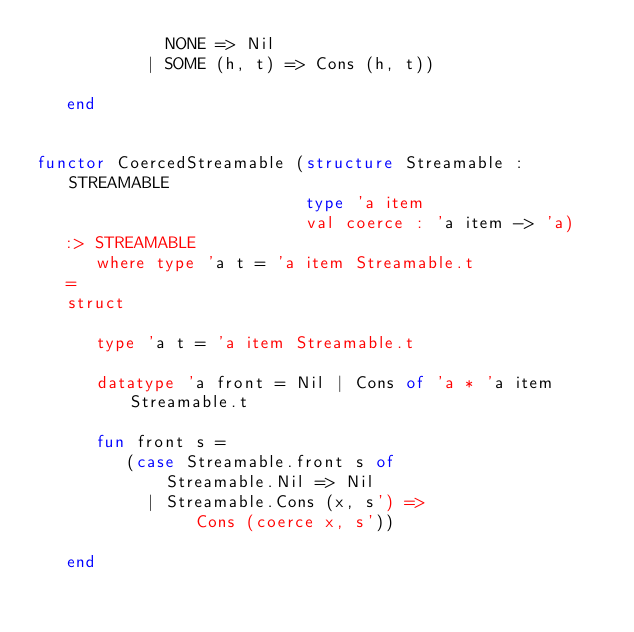Convert code to text. <code><loc_0><loc_0><loc_500><loc_500><_SML_>             NONE => Nil
           | SOME (h, t) => Cons (h, t))

   end


functor CoercedStreamable (structure Streamable : STREAMABLE
                           type 'a item
                           val coerce : 'a item -> 'a)
   :> STREAMABLE
      where type 'a t = 'a item Streamable.t
   =
   struct

      type 'a t = 'a item Streamable.t

      datatype 'a front = Nil | Cons of 'a * 'a item Streamable.t

      fun front s =
         (case Streamable.front s of
             Streamable.Nil => Nil
           | Streamable.Cons (x, s') =>
                Cons (coerce x, s'))

   end
</code> 